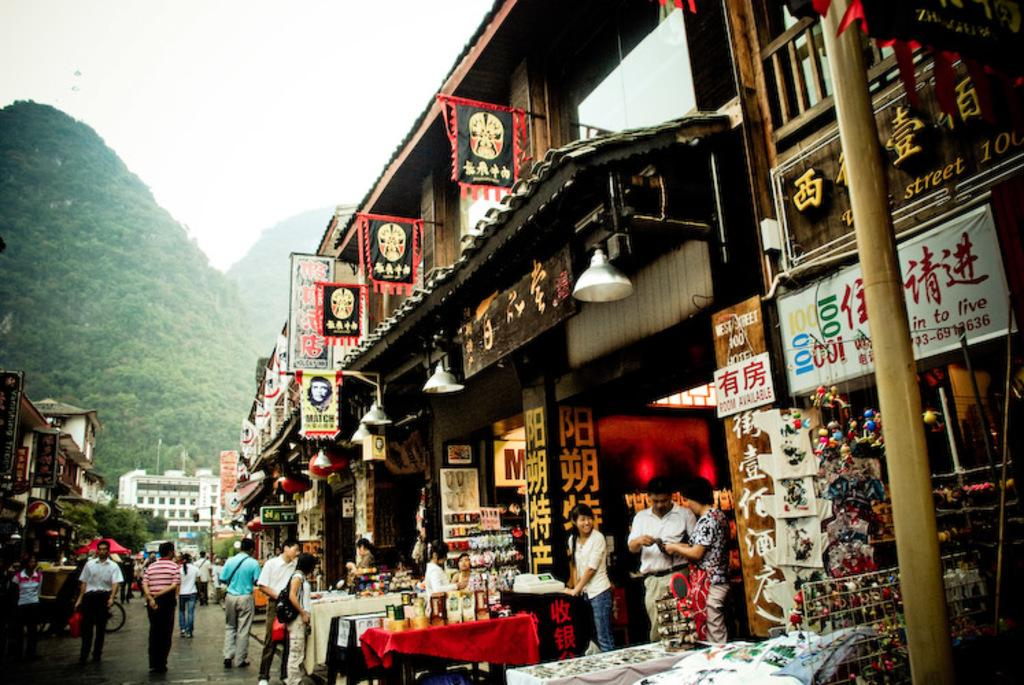Provide a one-sentence caption for the provided image. Many people are outside of West Street Hotel. 